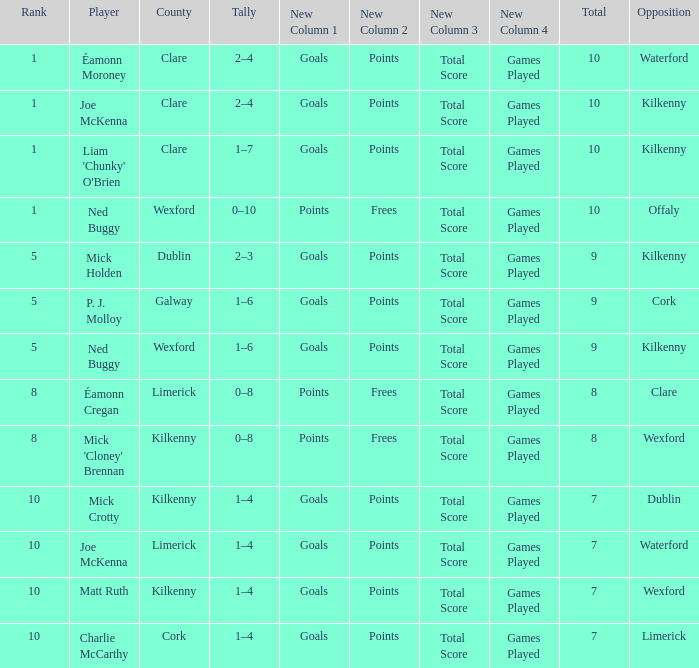Which Total has a County of kilkenny, and a Tally of 1–4, and a Rank larger than 10? None. 